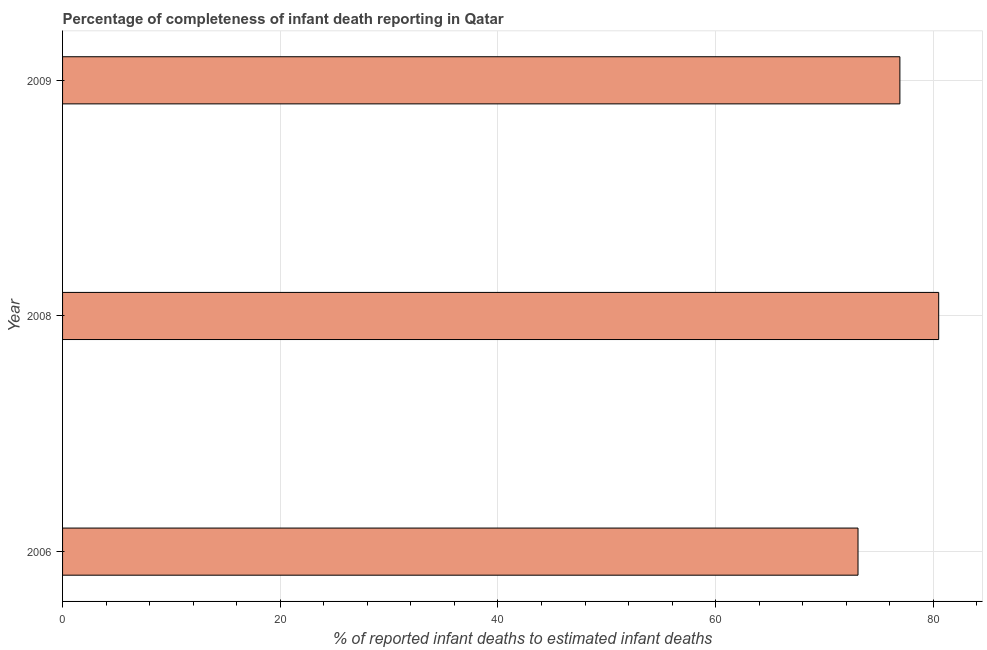Does the graph contain any zero values?
Make the answer very short. No. What is the title of the graph?
Make the answer very short. Percentage of completeness of infant death reporting in Qatar. What is the label or title of the X-axis?
Give a very brief answer. % of reported infant deaths to estimated infant deaths. What is the label or title of the Y-axis?
Keep it short and to the point. Year. What is the completeness of infant death reporting in 2009?
Offer a very short reply. 76.92. Across all years, what is the maximum completeness of infant death reporting?
Offer a terse response. 80.49. Across all years, what is the minimum completeness of infant death reporting?
Your answer should be very brief. 73.08. In which year was the completeness of infant death reporting minimum?
Provide a short and direct response. 2006. What is the sum of the completeness of infant death reporting?
Your answer should be compact. 230.49. What is the difference between the completeness of infant death reporting in 2008 and 2009?
Give a very brief answer. 3.56. What is the average completeness of infant death reporting per year?
Provide a short and direct response. 76.83. What is the median completeness of infant death reporting?
Provide a succinct answer. 76.92. What is the ratio of the completeness of infant death reporting in 2006 to that in 2008?
Ensure brevity in your answer.  0.91. Is the difference between the completeness of infant death reporting in 2006 and 2008 greater than the difference between any two years?
Offer a terse response. Yes. What is the difference between the highest and the second highest completeness of infant death reporting?
Provide a short and direct response. 3.56. Is the sum of the completeness of infant death reporting in 2008 and 2009 greater than the maximum completeness of infant death reporting across all years?
Your answer should be very brief. Yes. What is the difference between the highest and the lowest completeness of infant death reporting?
Ensure brevity in your answer.  7.41. In how many years, is the completeness of infant death reporting greater than the average completeness of infant death reporting taken over all years?
Offer a terse response. 2. How many bars are there?
Your answer should be compact. 3. What is the difference between two consecutive major ticks on the X-axis?
Offer a very short reply. 20. Are the values on the major ticks of X-axis written in scientific E-notation?
Give a very brief answer. No. What is the % of reported infant deaths to estimated infant deaths in 2006?
Provide a succinct answer. 73.08. What is the % of reported infant deaths to estimated infant deaths of 2008?
Make the answer very short. 80.49. What is the % of reported infant deaths to estimated infant deaths of 2009?
Provide a short and direct response. 76.92. What is the difference between the % of reported infant deaths to estimated infant deaths in 2006 and 2008?
Your answer should be very brief. -7.41. What is the difference between the % of reported infant deaths to estimated infant deaths in 2006 and 2009?
Give a very brief answer. -3.85. What is the difference between the % of reported infant deaths to estimated infant deaths in 2008 and 2009?
Provide a short and direct response. 3.56. What is the ratio of the % of reported infant deaths to estimated infant deaths in 2006 to that in 2008?
Provide a succinct answer. 0.91. What is the ratio of the % of reported infant deaths to estimated infant deaths in 2006 to that in 2009?
Offer a terse response. 0.95. What is the ratio of the % of reported infant deaths to estimated infant deaths in 2008 to that in 2009?
Ensure brevity in your answer.  1.05. 